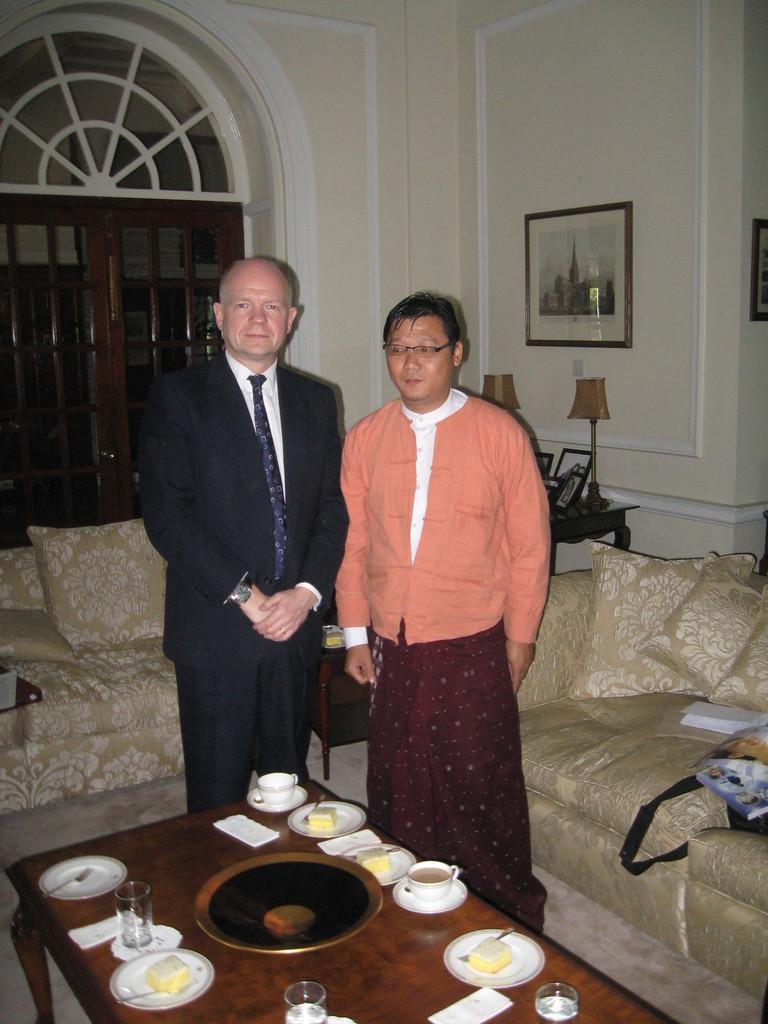In one or two sentences, can you explain what this image depicts? In this image we can see two persons are standing on the floor. There are few things placed on the table like cup and saucer, plate wit food, glass, spoons and forks. In the background we can see a sofa with pillows, photo frame, doors and table lamp. 